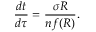<formula> <loc_0><loc_0><loc_500><loc_500>\frac { d t } { d \tau } = \frac { \sigma R } { n f ( R ) } .</formula> 